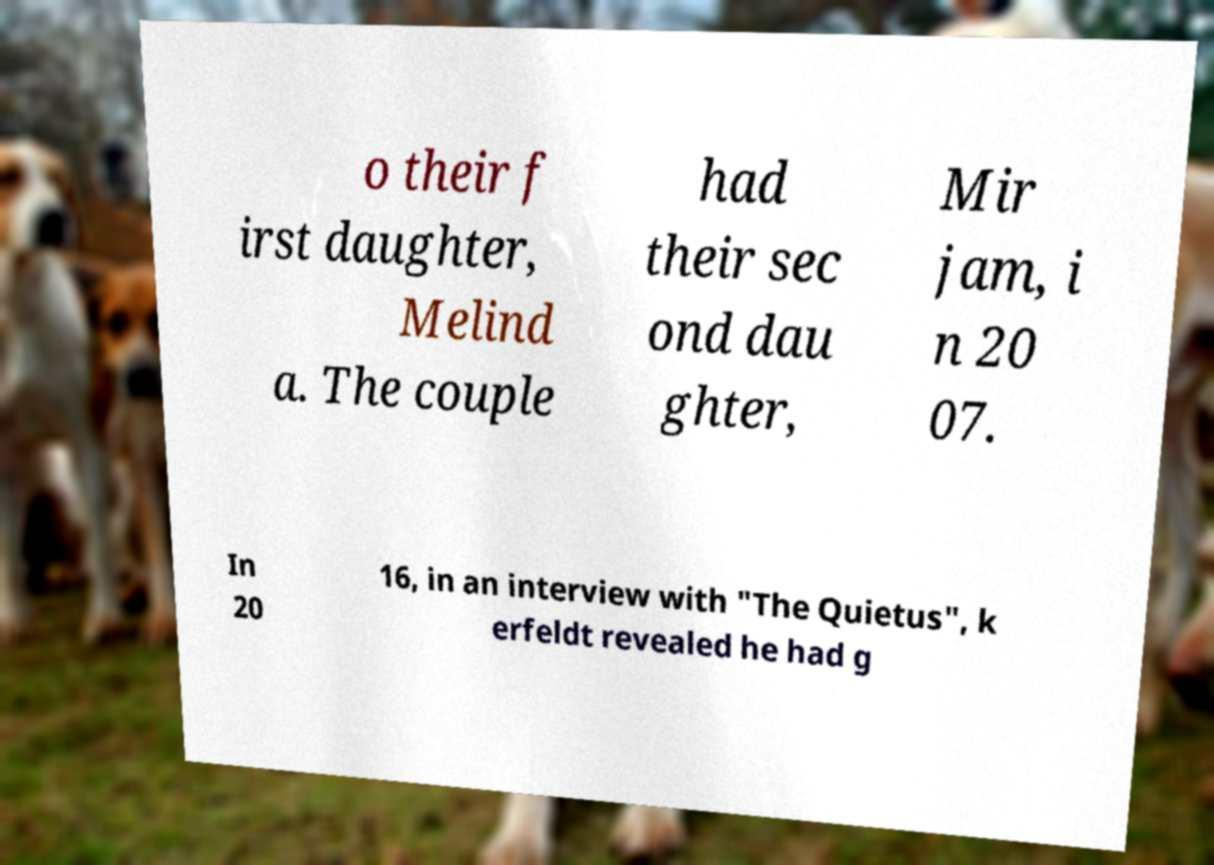Can you read and provide the text displayed in the image?This photo seems to have some interesting text. Can you extract and type it out for me? o their f irst daughter, Melind a. The couple had their sec ond dau ghter, Mir jam, i n 20 07. In 20 16, in an interview with "The Quietus", k erfeldt revealed he had g 